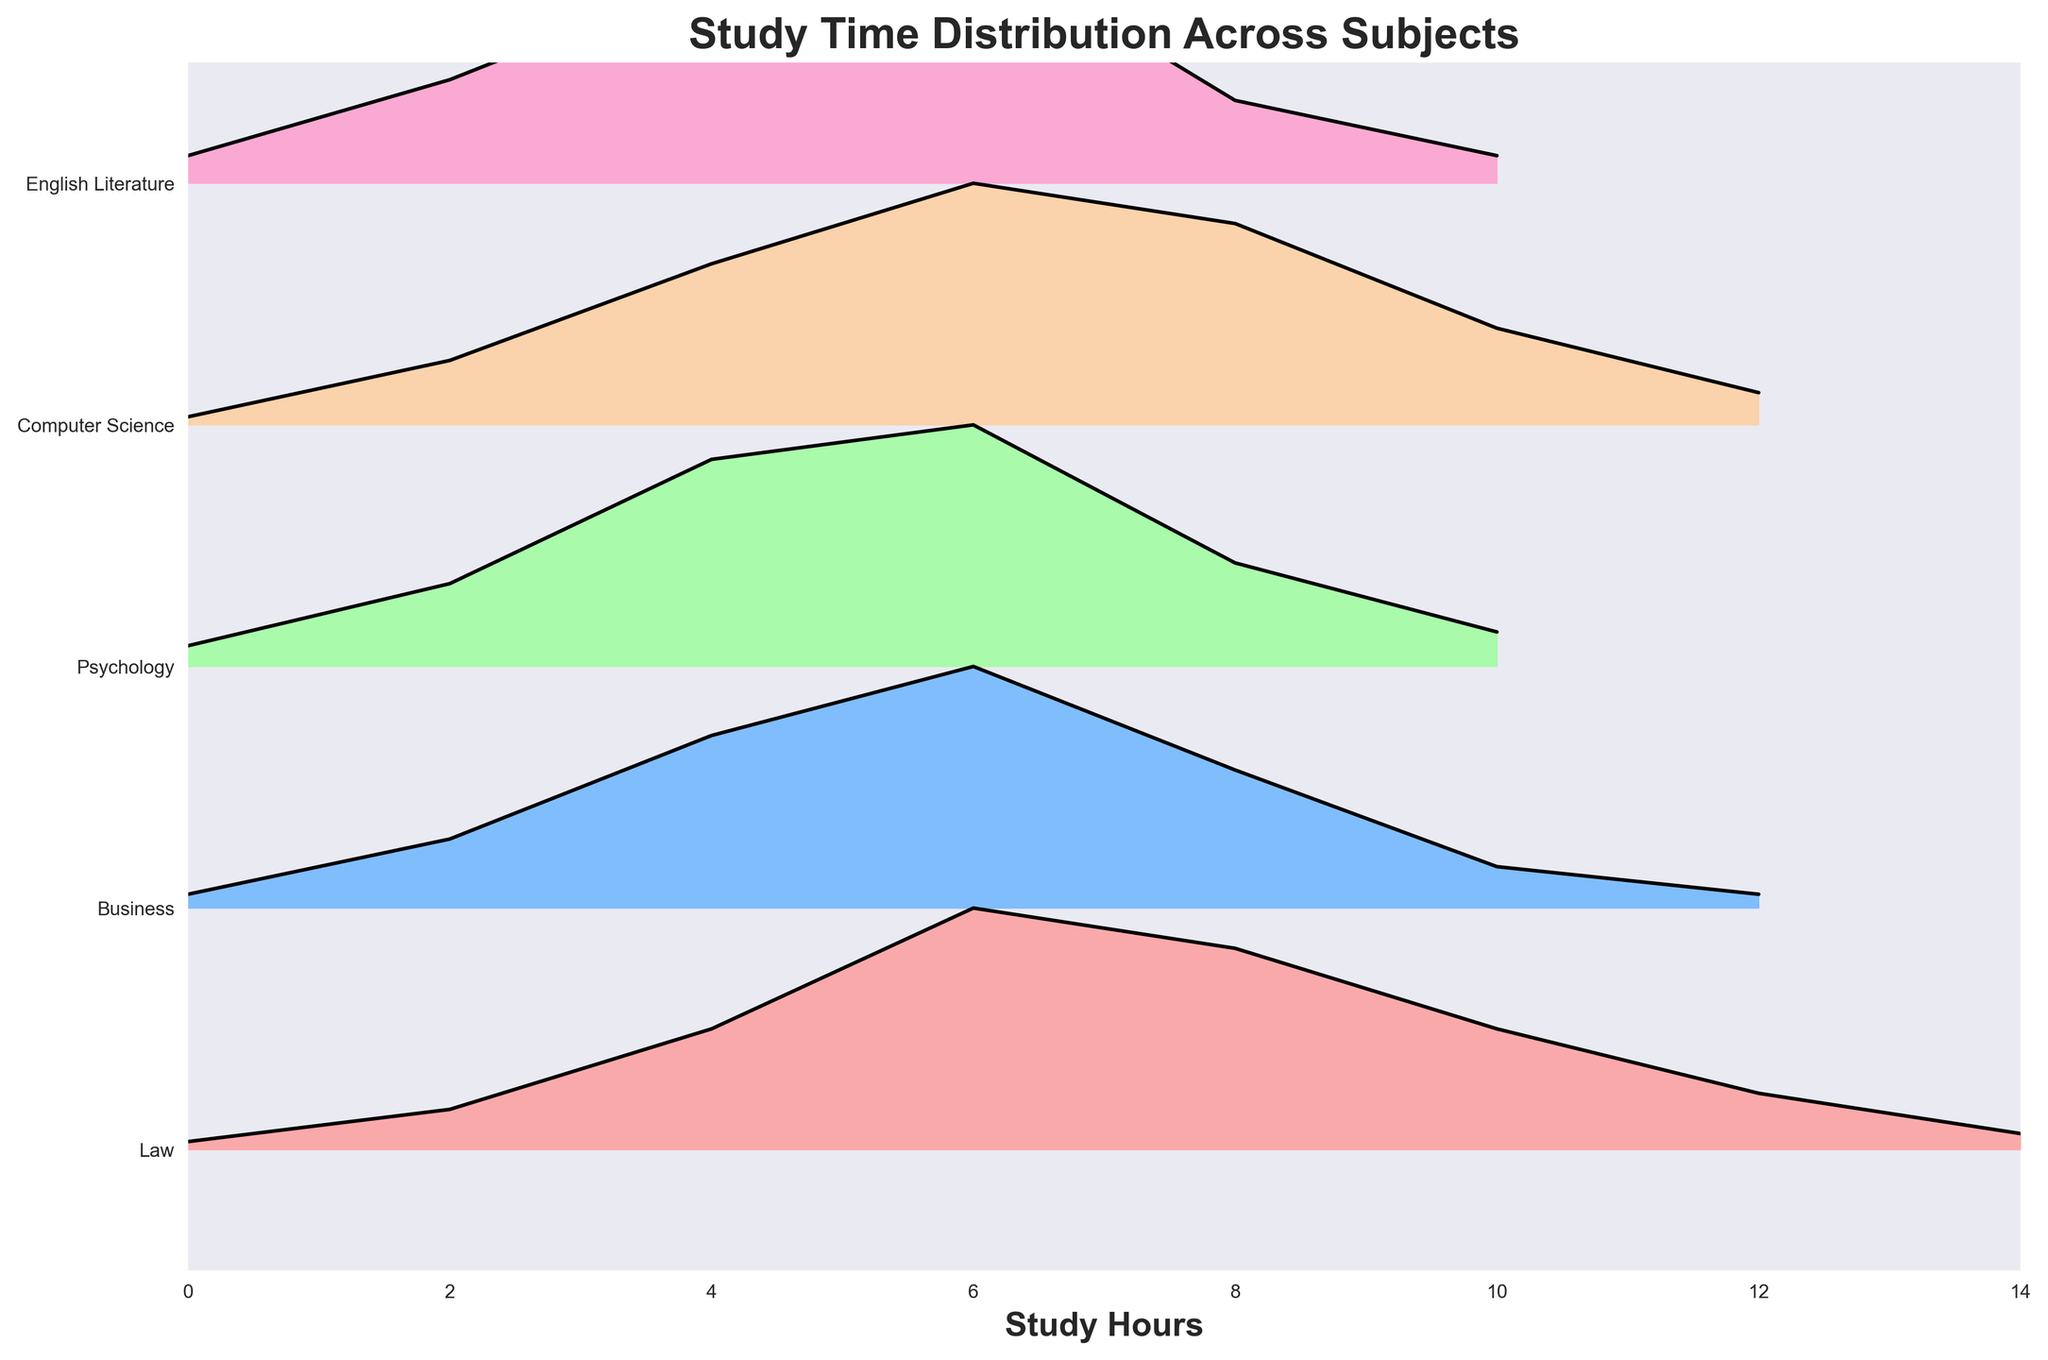What is the title of the figure? The title is written at the top-center of the figure. It says "Study Time Distribution Across Subjects".
Answer: Study Time Distribution Across Subjects Which subject has the highest density of students studying for 6 hours? By looking at the ridgeline areas, the peak density at the 6-hour mark seems highest for the subject 'English Literature'.
Answer: English Literature What is the range of hours displayed on the x-axis? The x-axis shows study hours, starting from 0 and going up to 14. This is clear from the scaling on the x-axis.
Answer: 0 to 14 Which subject shows the most balanced distribution of study times? By observing the shape of the density plots, subjects like 'Computer Science' and 'Psychology' show peaks spread over a range, indicating a more balanced distribution of study times compared to others.
Answer: Computer Science and Psychology How does the peak density of 'Business' at 8 hours compare to the other subjects? By observing the ridgeline plot, the density at the 8-hour mark for 'Business' is comparatively lower to the densities in 'Law' and 'Psychology' but higher than 'English Literature' and 'Computer Science'.
Answer: Lower than Law and Psychology, higher than English Literature and Computer Science How many subjects are compared in the figure? The figure displays ridgeline plots for 'Law', 'Business', 'Psychology', 'Computer Science', and 'English Literature'. Counting these gives us a total of 5 subjects.
Answer: 5 Which subject has the narrowest range of study hour densities concentrated at a peak? Observing the ridgeline plot shapes, 'Law' has the narrowest peak density, concentrated mainly around the 6-hour mark.
Answer: Law At 4 hours of study, which subject has the highest density? By inspecting the height of the ridgeline plots at the 4-hour mark, 'Psychology' has the highest density.
Answer: Psychology Of all the subjects shown, which two subjects have the most similar study time distributions? Comparing the shapes of the ridgeline plots, 'Computer Science' and 'English Literature' have a similarly high peak at 6 hours and a similar decrease in density towards both ends of the plot.
Answer: Computer Science and English Literature Which subject has a rising peak in density from 0 to 6 hours but a steep drop after that? Observing the density trends, 'Business' has an increasing peak up to 6 hours but drops steeply after that.
Answer: Business 